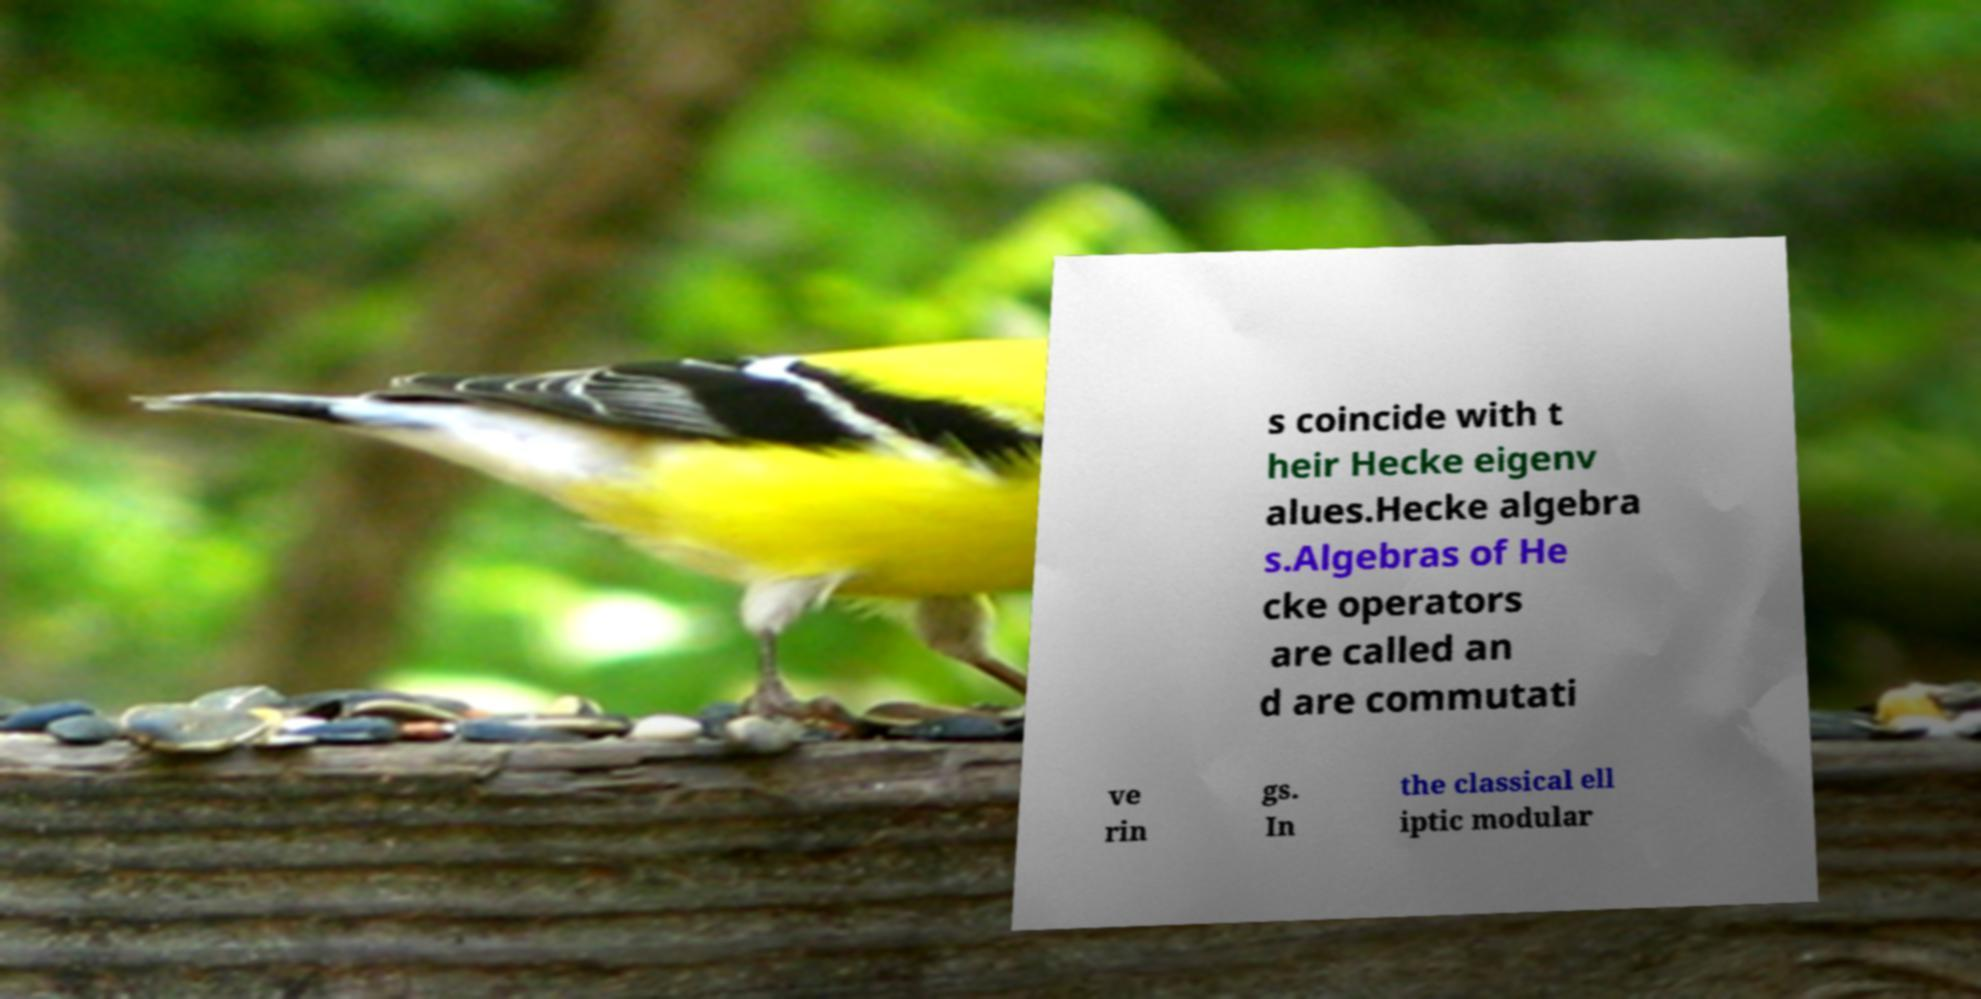For documentation purposes, I need the text within this image transcribed. Could you provide that? s coincide with t heir Hecke eigenv alues.Hecke algebra s.Algebras of He cke operators are called an d are commutati ve rin gs. In the classical ell iptic modular 